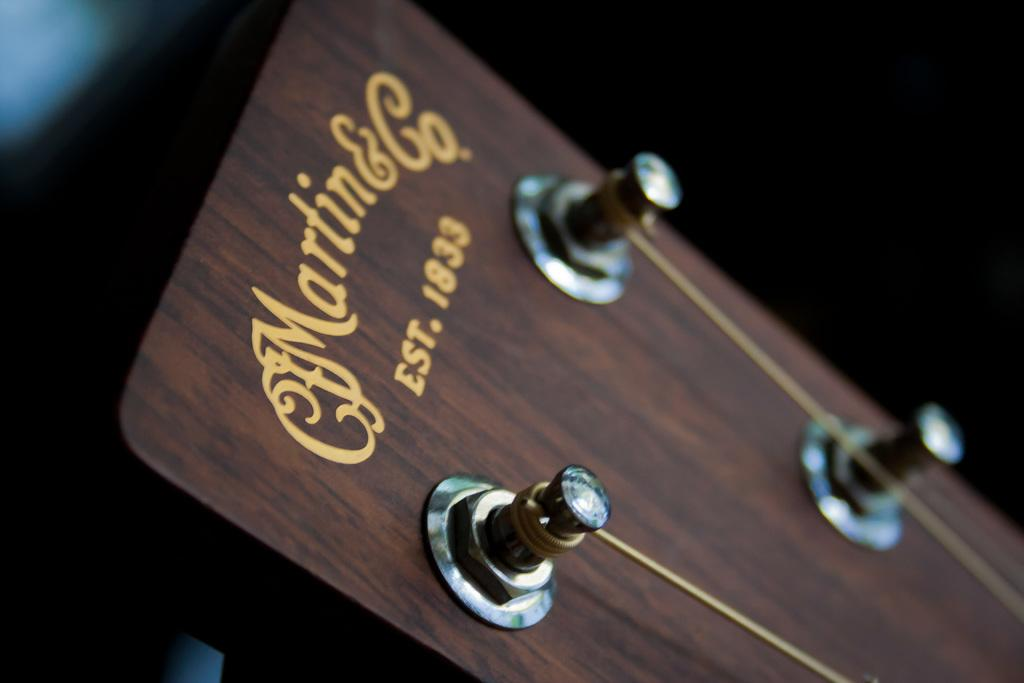What musical instrument is partially visible in the image? There is a part of a guitar in the image. What feature of the guitar can be seen in the image? The guitar has strings. What type of basin is used to hold the brass cat in the image? There is no basin, brass, or cat present in the image. 